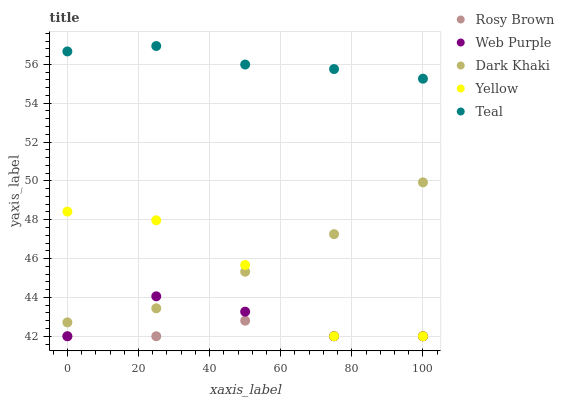Does Rosy Brown have the minimum area under the curve?
Answer yes or no. Yes. Does Teal have the maximum area under the curve?
Answer yes or no. Yes. Does Web Purple have the minimum area under the curve?
Answer yes or no. No. Does Web Purple have the maximum area under the curve?
Answer yes or no. No. Is Dark Khaki the smoothest?
Answer yes or no. Yes. Is Yellow the roughest?
Answer yes or no. Yes. Is Web Purple the smoothest?
Answer yes or no. No. Is Web Purple the roughest?
Answer yes or no. No. Does Web Purple have the lowest value?
Answer yes or no. Yes. Does Teal have the lowest value?
Answer yes or no. No. Does Teal have the highest value?
Answer yes or no. Yes. Does Web Purple have the highest value?
Answer yes or no. No. Is Yellow less than Teal?
Answer yes or no. Yes. Is Teal greater than Dark Khaki?
Answer yes or no. Yes. Does Dark Khaki intersect Yellow?
Answer yes or no. Yes. Is Dark Khaki less than Yellow?
Answer yes or no. No. Is Dark Khaki greater than Yellow?
Answer yes or no. No. Does Yellow intersect Teal?
Answer yes or no. No. 